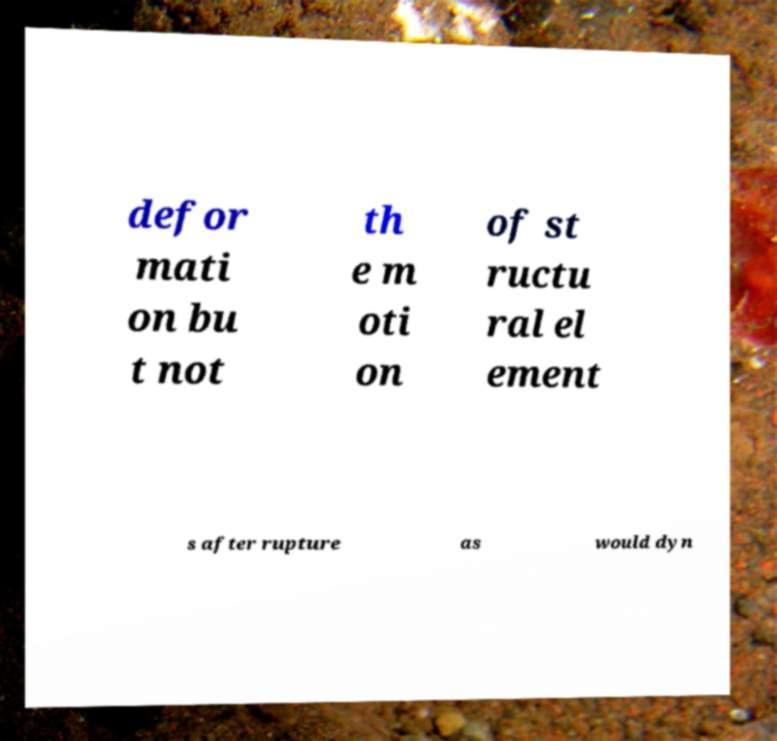Please identify and transcribe the text found in this image. defor mati on bu t not th e m oti on of st ructu ral el ement s after rupture as would dyn 